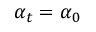Convert formula to latex. <formula><loc_0><loc_0><loc_500><loc_500>\alpha _ { t } = \alpha _ { 0 }</formula> 